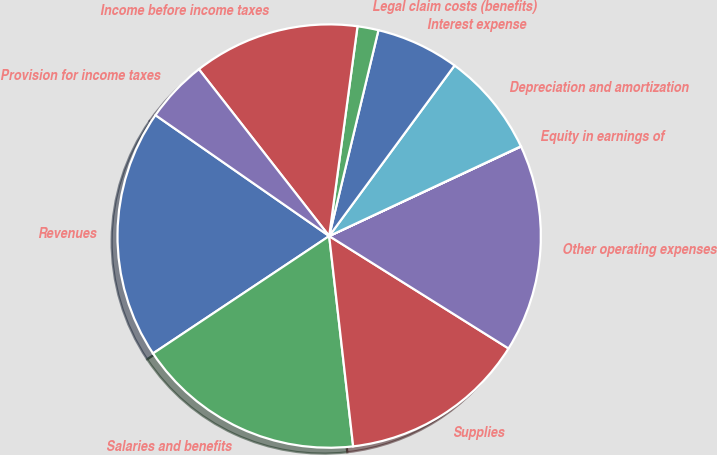<chart> <loc_0><loc_0><loc_500><loc_500><pie_chart><fcel>Revenues<fcel>Salaries and benefits<fcel>Supplies<fcel>Other operating expenses<fcel>Equity in earnings of<fcel>Depreciation and amortization<fcel>Interest expense<fcel>Legal claim costs (benefits)<fcel>Income before income taxes<fcel>Provision for income taxes<nl><fcel>19.03%<fcel>17.45%<fcel>14.28%<fcel>15.86%<fcel>0.02%<fcel>7.94%<fcel>6.35%<fcel>1.6%<fcel>12.69%<fcel>4.77%<nl></chart> 